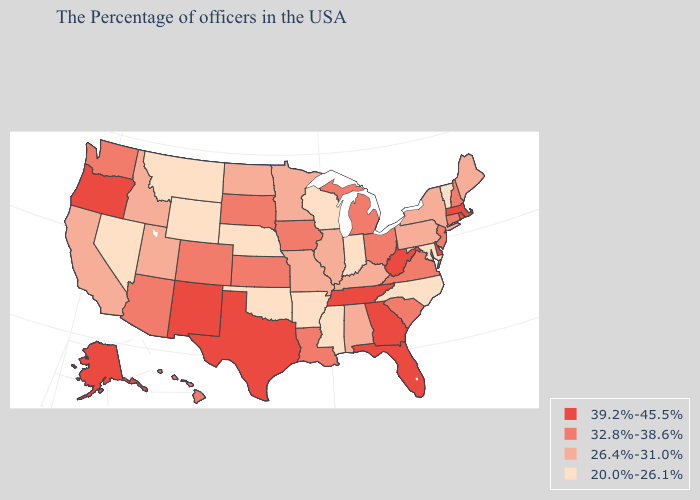Name the states that have a value in the range 20.0%-26.1%?
Concise answer only. Vermont, Maryland, North Carolina, Indiana, Wisconsin, Mississippi, Arkansas, Nebraska, Oklahoma, Wyoming, Montana, Nevada. What is the highest value in the USA?
Write a very short answer. 39.2%-45.5%. Does Vermont have the lowest value in the Northeast?
Be succinct. Yes. Among the states that border Colorado , does Kansas have the lowest value?
Keep it brief. No. Which states have the highest value in the USA?
Be succinct. Massachusetts, Rhode Island, Delaware, West Virginia, Florida, Georgia, Tennessee, Texas, New Mexico, Oregon, Alaska. What is the value of New Mexico?
Short answer required. 39.2%-45.5%. What is the value of Iowa?
Be succinct. 32.8%-38.6%. How many symbols are there in the legend?
Quick response, please. 4. Does Massachusetts have the same value as Maryland?
Quick response, please. No. Does Indiana have the lowest value in the USA?
Answer briefly. Yes. Is the legend a continuous bar?
Be succinct. No. Does South Carolina have a higher value than South Dakota?
Concise answer only. No. Among the states that border West Virginia , which have the lowest value?
Be succinct. Maryland. Does Rhode Island have the highest value in the USA?
Write a very short answer. Yes. How many symbols are there in the legend?
Quick response, please. 4. 